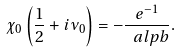<formula> <loc_0><loc_0><loc_500><loc_500>\chi _ { 0 } \left ( \frac { 1 } { 2 } + i \nu _ { 0 } \right ) = - \frac { e ^ { - 1 } } { \ a l p b } .</formula> 